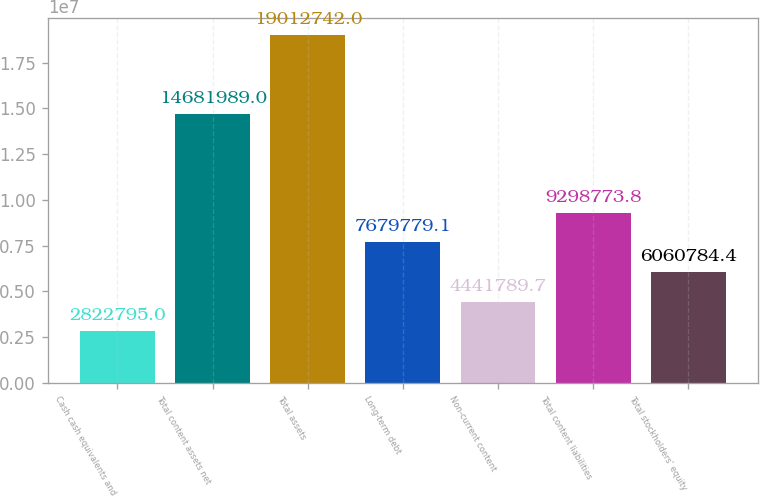<chart> <loc_0><loc_0><loc_500><loc_500><bar_chart><fcel>Cash cash equivalents and<fcel>Total content assets net<fcel>Total assets<fcel>Long-term debt<fcel>Non-current content<fcel>Total content liabilities<fcel>Total stockholders' equity<nl><fcel>2.8228e+06<fcel>1.4682e+07<fcel>1.90127e+07<fcel>7.67978e+06<fcel>4.44179e+06<fcel>9.29877e+06<fcel>6.06078e+06<nl></chart> 